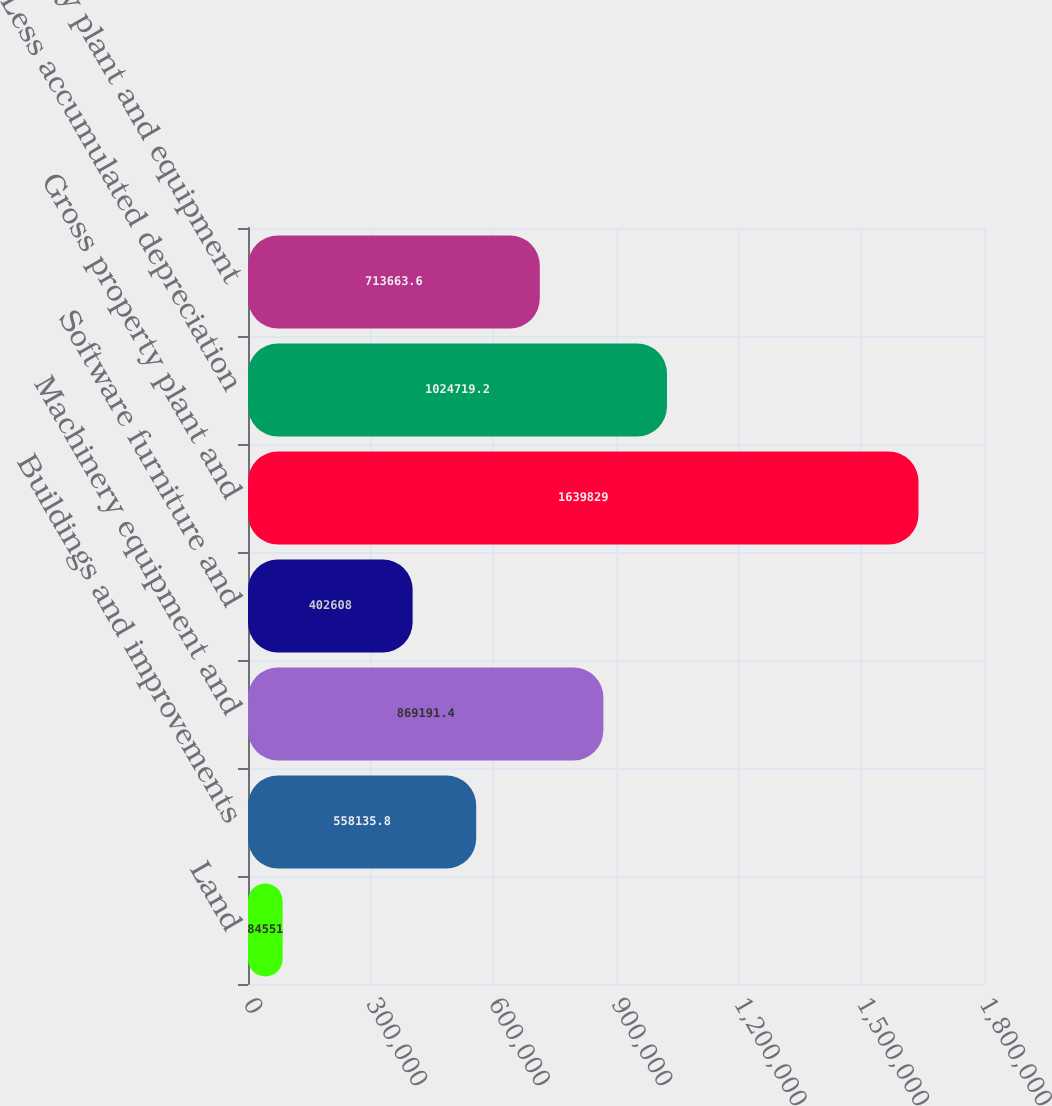Convert chart to OTSL. <chart><loc_0><loc_0><loc_500><loc_500><bar_chart><fcel>Land<fcel>Buildings and improvements<fcel>Machinery equipment and<fcel>Software furniture and<fcel>Gross property plant and<fcel>Less accumulated depreciation<fcel>Property plant and equipment<nl><fcel>84551<fcel>558136<fcel>869191<fcel>402608<fcel>1.63983e+06<fcel>1.02472e+06<fcel>713664<nl></chart> 